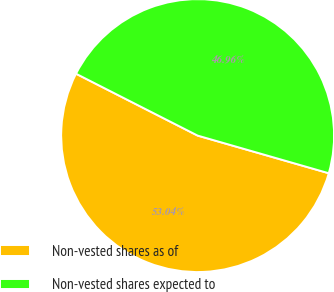<chart> <loc_0><loc_0><loc_500><loc_500><pie_chart><fcel>Non-vested shares as of<fcel>Non-vested shares expected to<nl><fcel>53.04%<fcel>46.96%<nl></chart> 